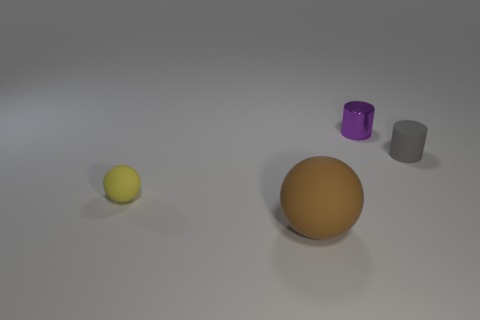Add 1 red shiny objects. How many objects exist? 5 Add 2 small things. How many small things exist? 5 Subtract 1 gray cylinders. How many objects are left? 3 Subtract all yellow matte things. Subtract all matte things. How many objects are left? 0 Add 1 small matte objects. How many small matte objects are left? 3 